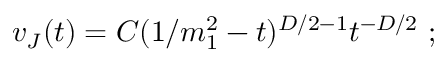Convert formula to latex. <formula><loc_0><loc_0><loc_500><loc_500>v _ { J } ( t ) = C ( 1 / m _ { 1 } ^ { 2 } - t ) ^ { D / 2 - 1 } t ^ { - D / 2 } \ ;</formula> 